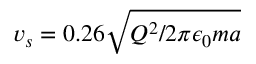Convert formula to latex. <formula><loc_0><loc_0><loc_500><loc_500>v _ { s } = 0 . 2 6 \sqrt { Q ^ { 2 } / 2 \pi \epsilon _ { 0 } m a }</formula> 